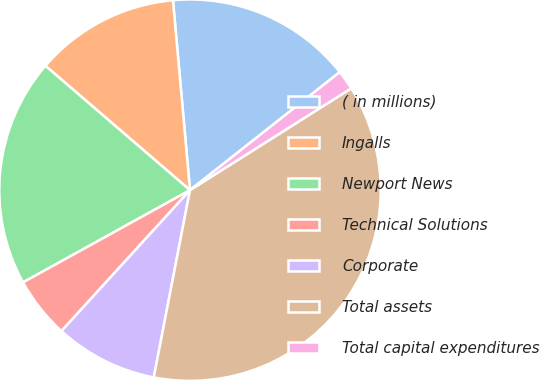<chart> <loc_0><loc_0><loc_500><loc_500><pie_chart><fcel>( in millions)<fcel>Ingalls<fcel>Newport News<fcel>Technical Solutions<fcel>Corporate<fcel>Total assets<fcel>Total capital expenditures<nl><fcel>15.8%<fcel>12.27%<fcel>19.34%<fcel>5.2%<fcel>8.73%<fcel>37.01%<fcel>1.66%<nl></chart> 